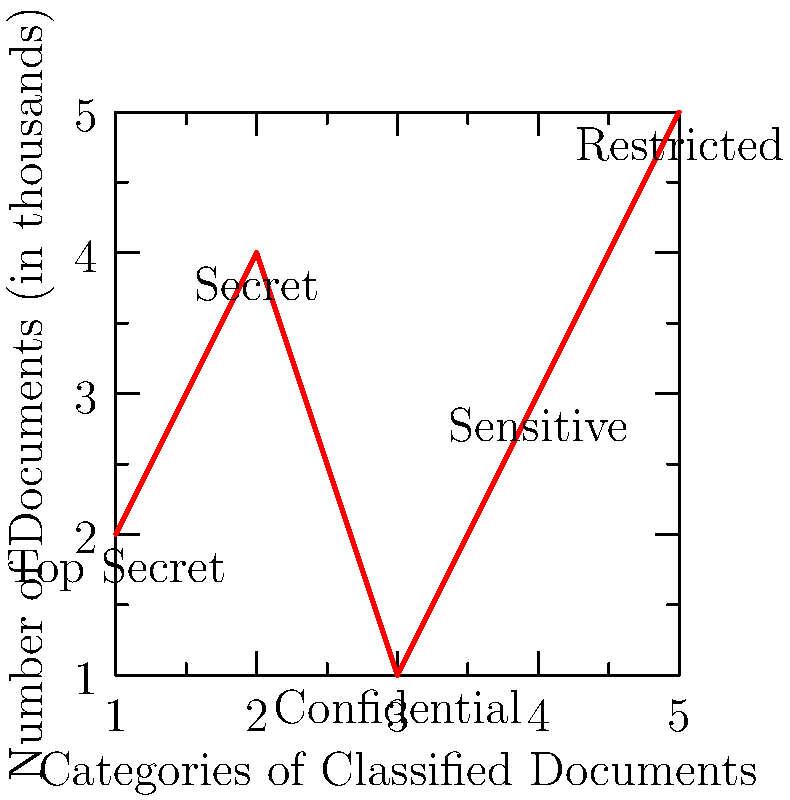As a First Amendment lawyer advising on government records access, you're analyzing classified document categories. Given the vector $\mathbf{a} = (2, 4, 1, 3, 5)$ representing thousands of documents in each category (Top Secret, Secret, Confidential, Sensitive, Restricted) and vector $\mathbf{b} = (5, 4, 3, 2, 1)$ representing their respective classification levels, calculate the dot product $\mathbf{a} \cdot \mathbf{b}$. What does this value signify in the context of document classification? To solve this problem, we'll follow these steps:

1) Recall that the dot product of two vectors $\mathbf{a} = (a_1, a_2, ..., a_n)$ and $\mathbf{b} = (b_1, b_2, ..., b_n)$ is defined as:

   $\mathbf{a} \cdot \mathbf{b} = a_1b_1 + a_2b_2 + ... + a_nb_n$

2) In our case:
   $\mathbf{a} = (2, 4, 1, 3, 5)$ (thousands of documents)
   $\mathbf{b} = (5, 4, 3, 2, 1)$ (classification levels)

3) Calculate each term:
   $(2 \times 5) + (4 \times 4) + (1 \times 3) + (3 \times 2) + (5 \times 1)$

4) Simplify:
   $10 + 16 + 3 + 6 + 5 = 40$

5) Interpret the result:
   The dot product is 40, which represents a weighted sum of classified documents. Each category is weighted by its classification level, giving more importance to higher classified documents. This single value provides a measure of the overall sensitivity of the document collection, considering both quantity and classification level.

In the context of document classification and First Amendment concerns, this weighted sum helps quantify the potential sensitivity of the entire collection, which could be relevant when advising on access to government records or assessing the overall secrecy level of a document set.
Answer: 40; weighted sum of classified documents considering quantity and sensitivity 